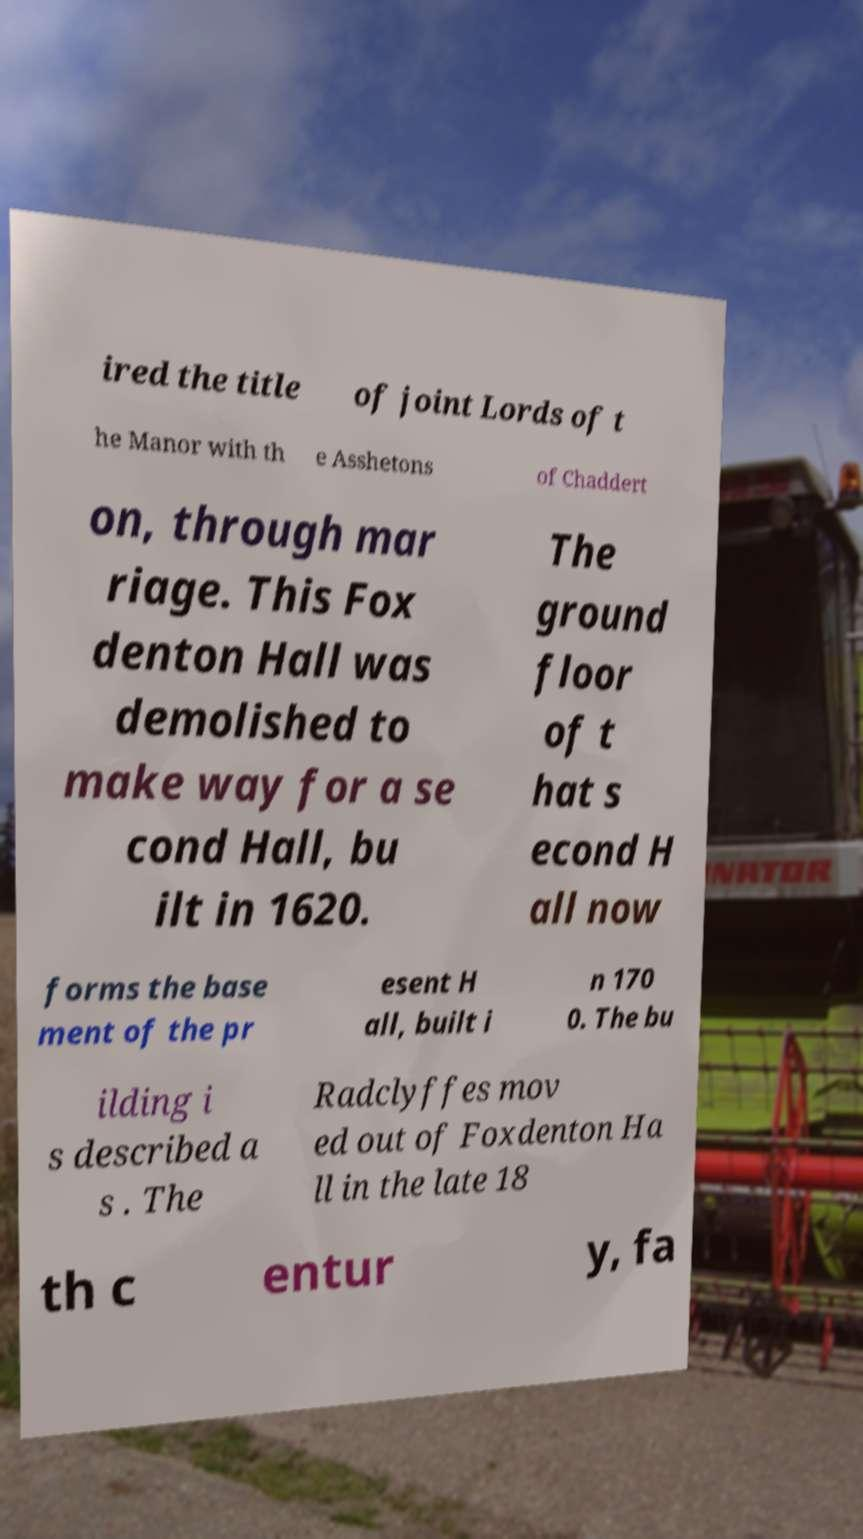Could you extract and type out the text from this image? ired the title of joint Lords of t he Manor with th e Asshetons of Chaddert on, through mar riage. This Fox denton Hall was demolished to make way for a se cond Hall, bu ilt in 1620. The ground floor of t hat s econd H all now forms the base ment of the pr esent H all, built i n 170 0. The bu ilding i s described a s . The Radclyffes mov ed out of Foxdenton Ha ll in the late 18 th c entur y, fa 